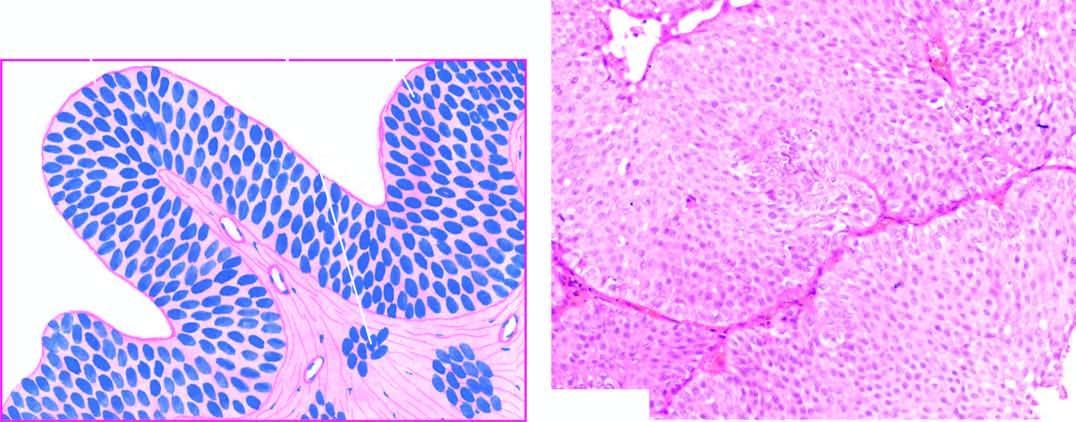what are the cells still recognisable as?
Answer the question using a single word or phrase. Of transitional origin and show features of anaplasia 